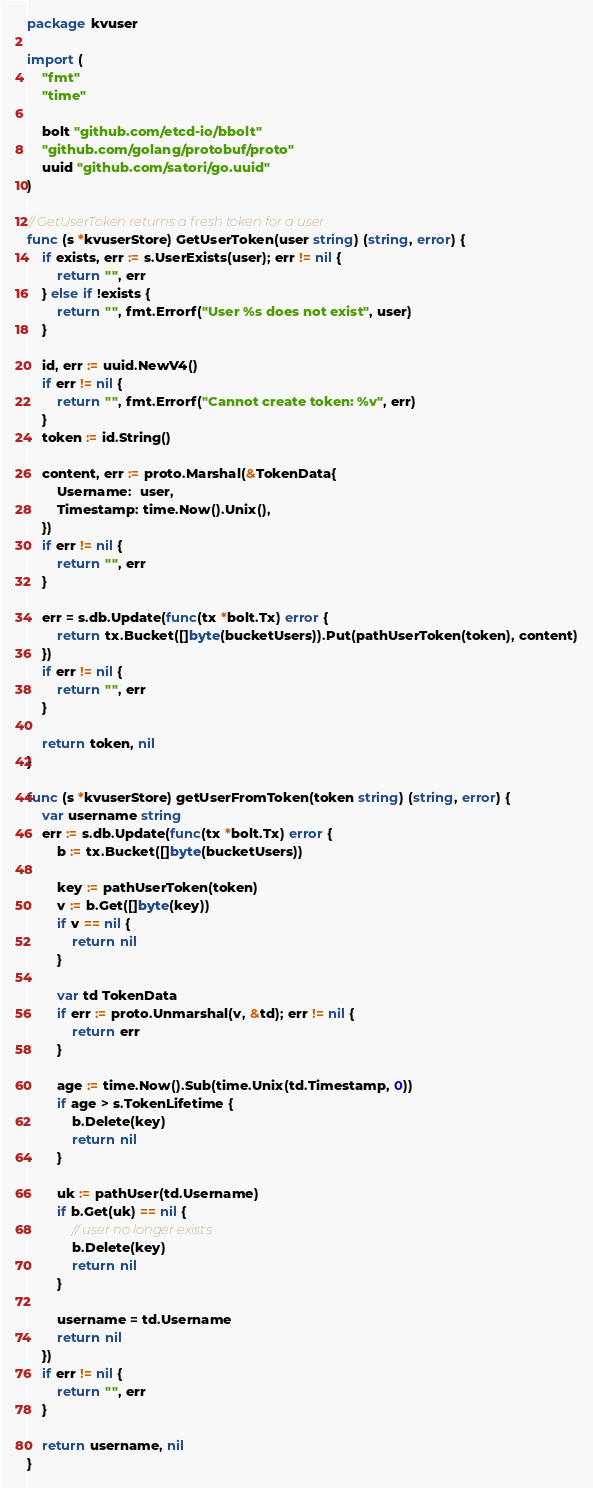<code> <loc_0><loc_0><loc_500><loc_500><_Go_>package kvuser

import (
	"fmt"
	"time"

	bolt "github.com/etcd-io/bbolt"
	"github.com/golang/protobuf/proto"
	uuid "github.com/satori/go.uuid"
)

// GetUserToken returns a fresh token for a user
func (s *kvuserStore) GetUserToken(user string) (string, error) {
	if exists, err := s.UserExists(user); err != nil {
		return "", err
	} else if !exists {
		return "", fmt.Errorf("User %s does not exist", user)
	}

	id, err := uuid.NewV4()
	if err != nil {
		return "", fmt.Errorf("Cannot create token: %v", err)
	}
	token := id.String()

	content, err := proto.Marshal(&TokenData{
		Username:  user,
		Timestamp: time.Now().Unix(),
	})
	if err != nil {
		return "", err
	}

	err = s.db.Update(func(tx *bolt.Tx) error {
		return tx.Bucket([]byte(bucketUsers)).Put(pathUserToken(token), content)
	})
	if err != nil {
		return "", err
	}

	return token, nil
}

func (s *kvuserStore) getUserFromToken(token string) (string, error) {
	var username string
	err := s.db.Update(func(tx *bolt.Tx) error {
		b := tx.Bucket([]byte(bucketUsers))

		key := pathUserToken(token)
		v := b.Get([]byte(key))
		if v == nil {
			return nil
		}

		var td TokenData
		if err := proto.Unmarshal(v, &td); err != nil {
			return err
		}

		age := time.Now().Sub(time.Unix(td.Timestamp, 0))
		if age > s.TokenLifetime {
			b.Delete(key)
			return nil
		}

		uk := pathUser(td.Username)
		if b.Get(uk) == nil {
			// user no longer exists
			b.Delete(key)
			return nil
		}

		username = td.Username
		return nil
	})
	if err != nil {
		return "", err
	}

	return username, nil
}
</code> 